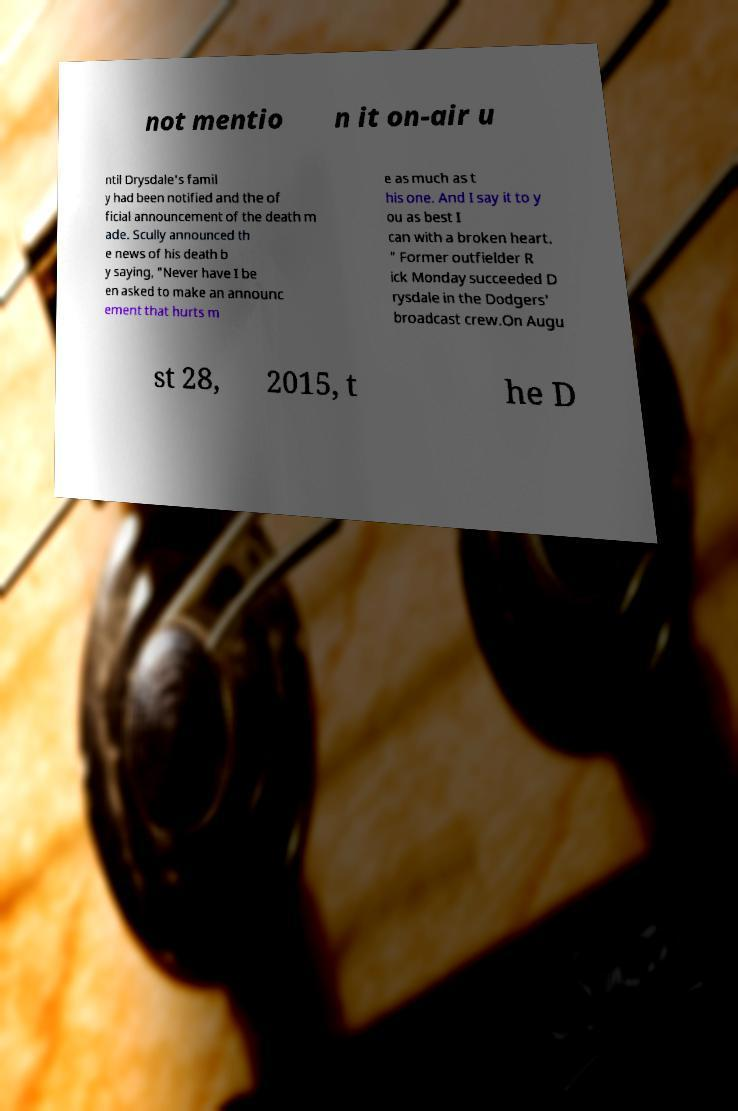Could you extract and type out the text from this image? not mentio n it on-air u ntil Drysdale's famil y had been notified and the of ficial announcement of the death m ade. Scully announced th e news of his death b y saying, "Never have I be en asked to make an announc ement that hurts m e as much as t his one. And I say it to y ou as best I can with a broken heart. " Former outfielder R ick Monday succeeded D rysdale in the Dodgers' broadcast crew.On Augu st 28, 2015, t he D 